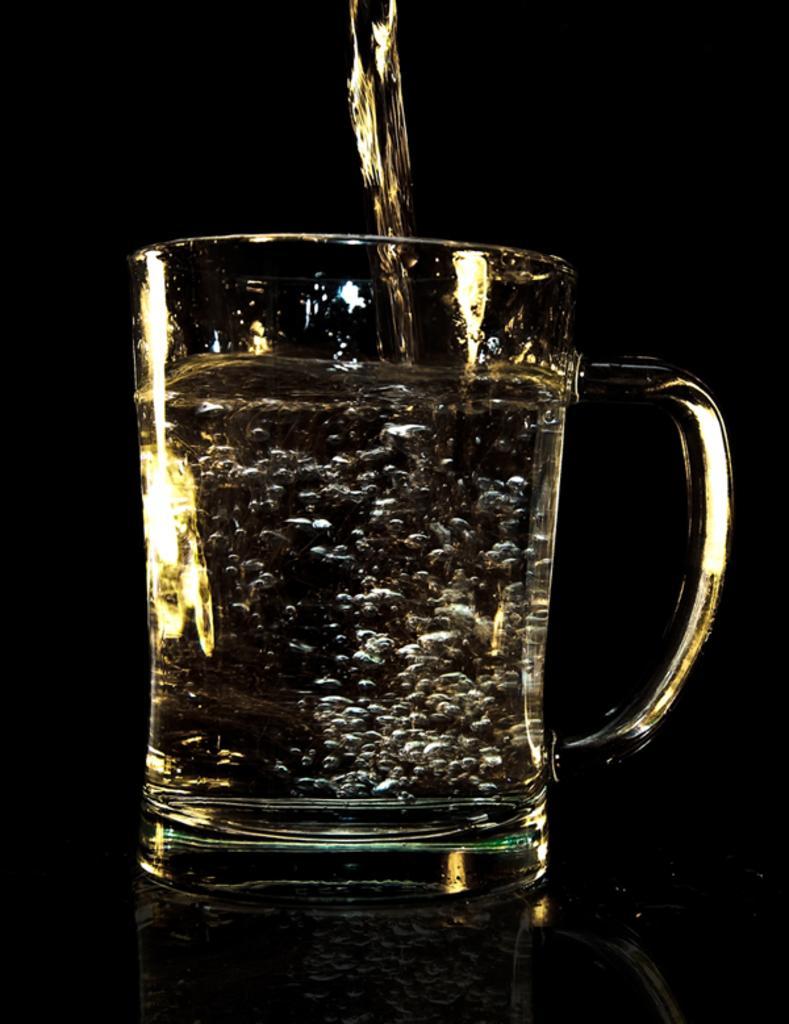Can you describe this image briefly? In this picture there is a glass and a water. 